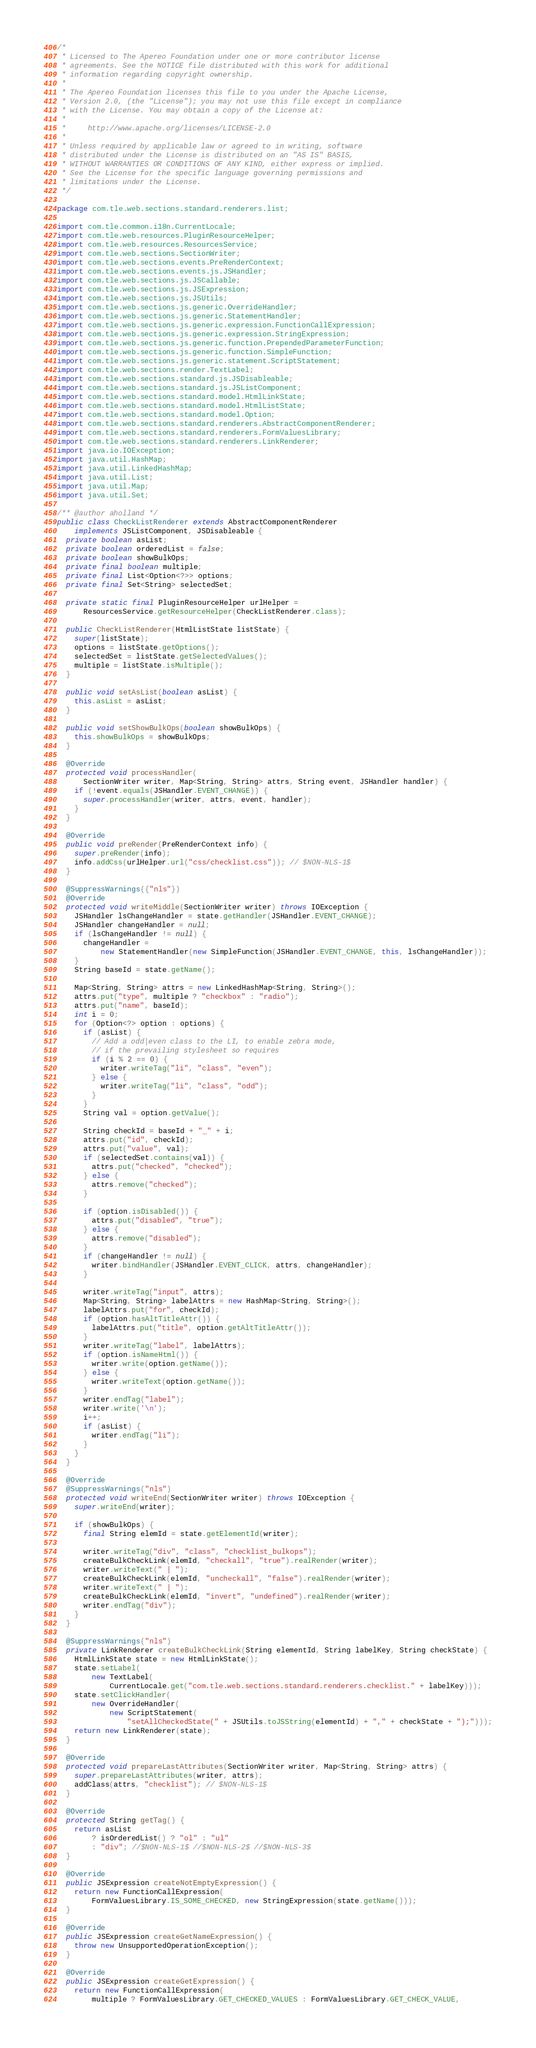Convert code to text. <code><loc_0><loc_0><loc_500><loc_500><_Java_>/*
 * Licensed to The Apereo Foundation under one or more contributor license
 * agreements. See the NOTICE file distributed with this work for additional
 * information regarding copyright ownership.
 *
 * The Apereo Foundation licenses this file to you under the Apache License,
 * Version 2.0, (the "License"); you may not use this file except in compliance
 * with the License. You may obtain a copy of the License at:
 *
 *     http://www.apache.org/licenses/LICENSE-2.0
 *
 * Unless required by applicable law or agreed to in writing, software
 * distributed under the License is distributed on an "AS IS" BASIS,
 * WITHOUT WARRANTIES OR CONDITIONS OF ANY KIND, either express or implied.
 * See the License for the specific language governing permissions and
 * limitations under the License.
 */

package com.tle.web.sections.standard.renderers.list;

import com.tle.common.i18n.CurrentLocale;
import com.tle.web.resources.PluginResourceHelper;
import com.tle.web.resources.ResourcesService;
import com.tle.web.sections.SectionWriter;
import com.tle.web.sections.events.PreRenderContext;
import com.tle.web.sections.events.js.JSHandler;
import com.tle.web.sections.js.JSCallable;
import com.tle.web.sections.js.JSExpression;
import com.tle.web.sections.js.JSUtils;
import com.tle.web.sections.js.generic.OverrideHandler;
import com.tle.web.sections.js.generic.StatementHandler;
import com.tle.web.sections.js.generic.expression.FunctionCallExpression;
import com.tle.web.sections.js.generic.expression.StringExpression;
import com.tle.web.sections.js.generic.function.PrependedParameterFunction;
import com.tle.web.sections.js.generic.function.SimpleFunction;
import com.tle.web.sections.js.generic.statement.ScriptStatement;
import com.tle.web.sections.render.TextLabel;
import com.tle.web.sections.standard.js.JSDisableable;
import com.tle.web.sections.standard.js.JSListComponent;
import com.tle.web.sections.standard.model.HtmlLinkState;
import com.tle.web.sections.standard.model.HtmlListState;
import com.tle.web.sections.standard.model.Option;
import com.tle.web.sections.standard.renderers.AbstractComponentRenderer;
import com.tle.web.sections.standard.renderers.FormValuesLibrary;
import com.tle.web.sections.standard.renderers.LinkRenderer;
import java.io.IOException;
import java.util.HashMap;
import java.util.LinkedHashMap;
import java.util.List;
import java.util.Map;
import java.util.Set;

/** @author aholland */
public class CheckListRenderer extends AbstractComponentRenderer
    implements JSListComponent, JSDisableable {
  private boolean asList;
  private boolean orderedList = false;
  private boolean showBulkOps;
  private final boolean multiple;
  private final List<Option<?>> options;
  private final Set<String> selectedSet;

  private static final PluginResourceHelper urlHelper =
      ResourcesService.getResourceHelper(CheckListRenderer.class);

  public CheckListRenderer(HtmlListState listState) {
    super(listState);
    options = listState.getOptions();
    selectedSet = listState.getSelectedValues();
    multiple = listState.isMultiple();
  }

  public void setAsList(boolean asList) {
    this.asList = asList;
  }

  public void setShowBulkOps(boolean showBulkOps) {
    this.showBulkOps = showBulkOps;
  }

  @Override
  protected void processHandler(
      SectionWriter writer, Map<String, String> attrs, String event, JSHandler handler) {
    if (!event.equals(JSHandler.EVENT_CHANGE)) {
      super.processHandler(writer, attrs, event, handler);
    }
  }

  @Override
  public void preRender(PreRenderContext info) {
    super.preRender(info);
    info.addCss(urlHelper.url("css/checklist.css")); // $NON-NLS-1$
  }

  @SuppressWarnings({"nls"})
  @Override
  protected void writeMiddle(SectionWriter writer) throws IOException {
    JSHandler lsChangeHandler = state.getHandler(JSHandler.EVENT_CHANGE);
    JSHandler changeHandler = null;
    if (lsChangeHandler != null) {
      changeHandler =
          new StatementHandler(new SimpleFunction(JSHandler.EVENT_CHANGE, this, lsChangeHandler));
    }
    String baseId = state.getName();

    Map<String, String> attrs = new LinkedHashMap<String, String>();
    attrs.put("type", multiple ? "checkbox" : "radio");
    attrs.put("name", baseId);
    int i = 0;
    for (Option<?> option : options) {
      if (asList) {
        // Add a odd|even class to the LI, to enable zebra mode,
        // if the prevailing stylesheet so requires
        if (i % 2 == 0) {
          writer.writeTag("li", "class", "even");
        } else {
          writer.writeTag("li", "class", "odd");
        }
      }
      String val = option.getValue();

      String checkId = baseId + "_" + i;
      attrs.put("id", checkId);
      attrs.put("value", val);
      if (selectedSet.contains(val)) {
        attrs.put("checked", "checked");
      } else {
        attrs.remove("checked");
      }

      if (option.isDisabled()) {
        attrs.put("disabled", "true");
      } else {
        attrs.remove("disabled");
      }
      if (changeHandler != null) {
        writer.bindHandler(JSHandler.EVENT_CLICK, attrs, changeHandler);
      }

      writer.writeTag("input", attrs);
      Map<String, String> labelAttrs = new HashMap<String, String>();
      labelAttrs.put("for", checkId);
      if (option.hasAltTitleAttr()) {
        labelAttrs.put("title", option.getAltTitleAttr());
      }
      writer.writeTag("label", labelAttrs);
      if (option.isNameHtml()) {
        writer.write(option.getName());
      } else {
        writer.writeText(option.getName());
      }
      writer.endTag("label");
      writer.write('\n');
      i++;
      if (asList) {
        writer.endTag("li");
      }
    }
  }

  @Override
  @SuppressWarnings("nls")
  protected void writeEnd(SectionWriter writer) throws IOException {
    super.writeEnd(writer);

    if (showBulkOps) {
      final String elemId = state.getElementId(writer);

      writer.writeTag("div", "class", "checklist_bulkops");
      createBulkCheckLink(elemId, "checkall", "true").realRender(writer);
      writer.writeText(" | ");
      createBulkCheckLink(elemId, "uncheckall", "false").realRender(writer);
      writer.writeText(" | ");
      createBulkCheckLink(elemId, "invert", "undefined").realRender(writer);
      writer.endTag("div");
    }
  }

  @SuppressWarnings("nls")
  private LinkRenderer createBulkCheckLink(String elementId, String labelKey, String checkState) {
    HtmlLinkState state = new HtmlLinkState();
    state.setLabel(
        new TextLabel(
            CurrentLocale.get("com.tle.web.sections.standard.renderers.checklist." + labelKey)));
    state.setClickHandler(
        new OverrideHandler(
            new ScriptStatement(
                "setAllCheckedState(" + JSUtils.toJSString(elementId) + "," + checkState + ");")));
    return new LinkRenderer(state);
  }

  @Override
  protected void prepareLastAttributes(SectionWriter writer, Map<String, String> attrs) {
    super.prepareLastAttributes(writer, attrs);
    addClass(attrs, "checklist"); // $NON-NLS-1$
  }

  @Override
  protected String getTag() {
    return asList
        ? isOrderedList() ? "ol" : "ul"
        : "div"; //$NON-NLS-1$ //$NON-NLS-2$ //$NON-NLS-3$
  }

  @Override
  public JSExpression createNotEmptyExpression() {
    return new FunctionCallExpression(
        FormValuesLibrary.IS_SOME_CHECKED, new StringExpression(state.getName()));
  }

  @Override
  public JSExpression createGetNameExpression() {
    throw new UnsupportedOperationException();
  }

  @Override
  public JSExpression createGetExpression() {
    return new FunctionCallExpression(
        multiple ? FormValuesLibrary.GET_CHECKED_VALUES : FormValuesLibrary.GET_CHECK_VALUE,</code> 